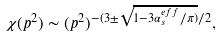<formula> <loc_0><loc_0><loc_500><loc_500>\chi ( p ^ { 2 } ) \sim ( p ^ { 2 } ) ^ { - ( 3 \pm \sqrt { 1 - 3 \alpha _ { s } ^ { e f f } / \pi ) } / 2 } ,</formula> 